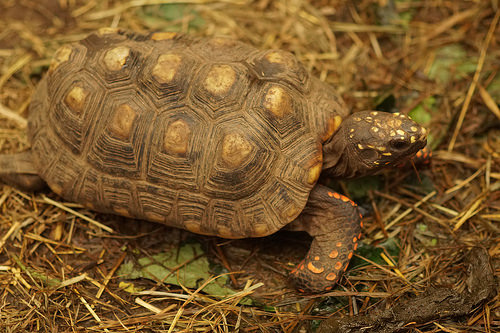<image>
Is the turtle behind the dry leaf? Yes. From this viewpoint, the turtle is positioned behind the dry leaf, with the dry leaf partially or fully occluding the turtle. 